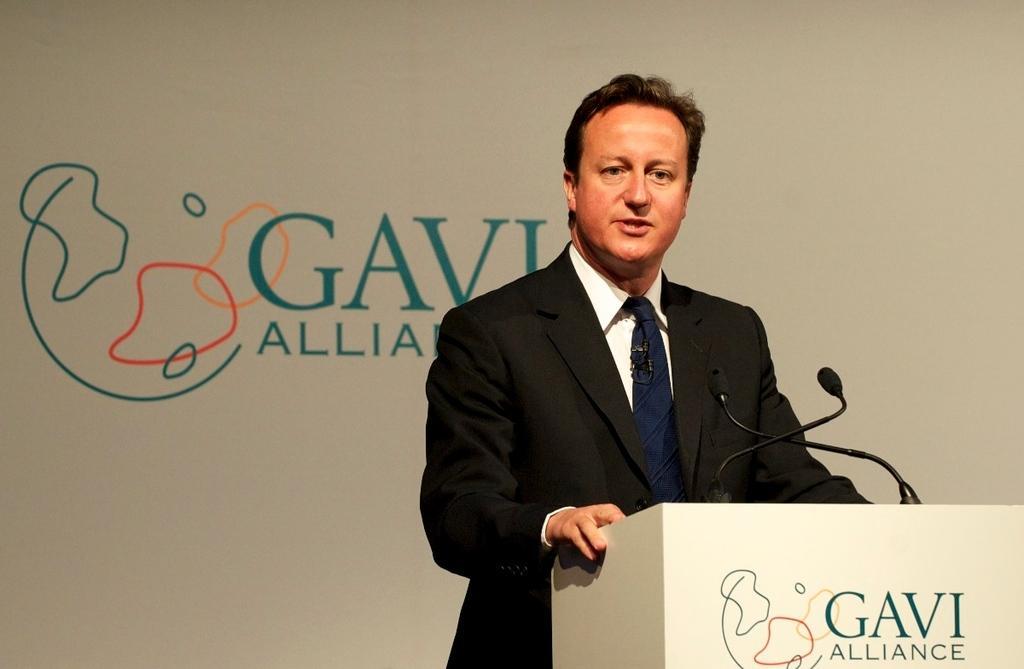How would you summarize this image in a sentence or two? In the picture I can see a man is standing in front of a podium. On the podium I can see microphones. The man is wearing suit, and tie and a white color shirt. In the background I can see something written on the wall. 